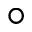Convert formula to latex. <formula><loc_0><loc_0><loc_500><loc_500>^ { \circ }</formula> 